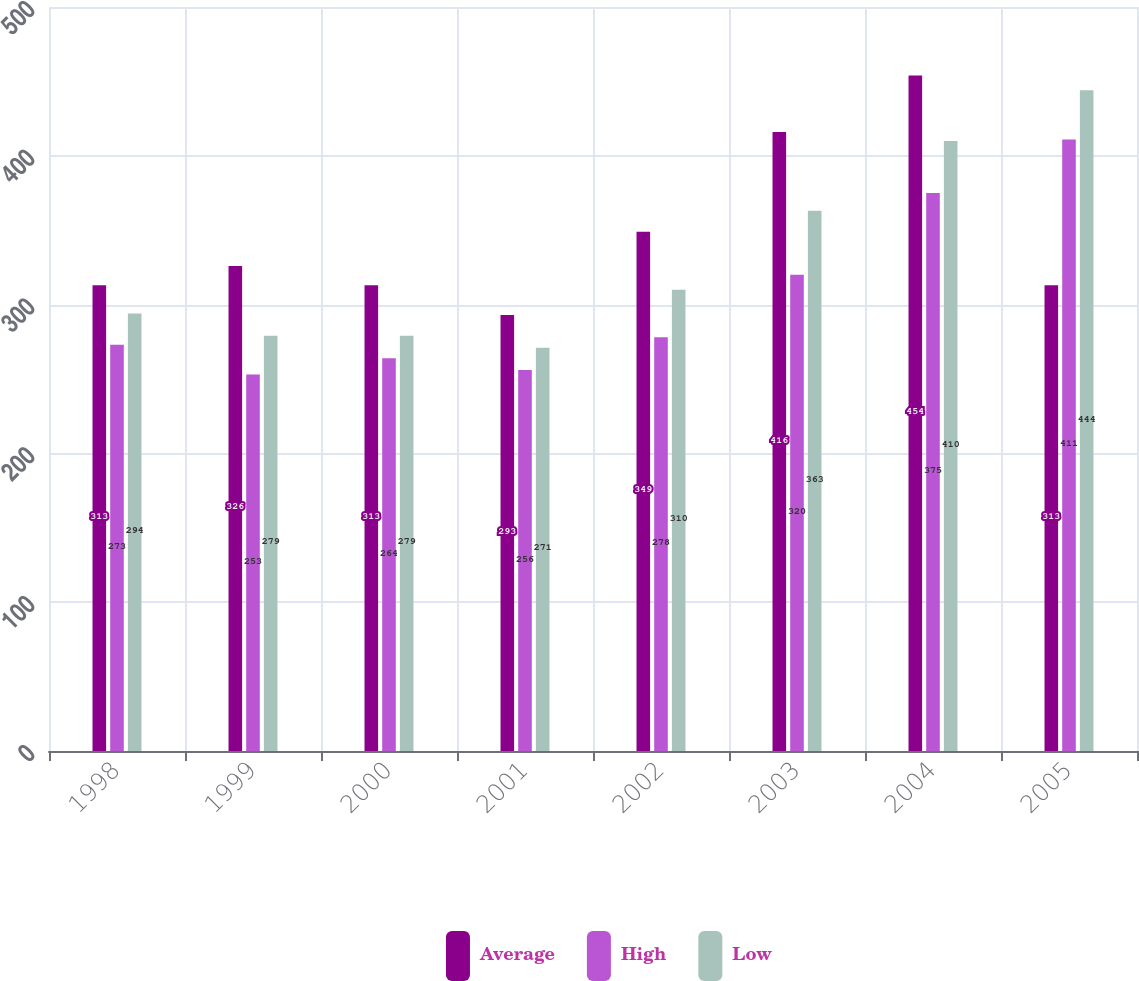Convert chart to OTSL. <chart><loc_0><loc_0><loc_500><loc_500><stacked_bar_chart><ecel><fcel>1998<fcel>1999<fcel>2000<fcel>2001<fcel>2002<fcel>2003<fcel>2004<fcel>2005<nl><fcel>Average<fcel>313<fcel>326<fcel>313<fcel>293<fcel>349<fcel>416<fcel>454<fcel>313<nl><fcel>High<fcel>273<fcel>253<fcel>264<fcel>256<fcel>278<fcel>320<fcel>375<fcel>411<nl><fcel>Low<fcel>294<fcel>279<fcel>279<fcel>271<fcel>310<fcel>363<fcel>410<fcel>444<nl></chart> 